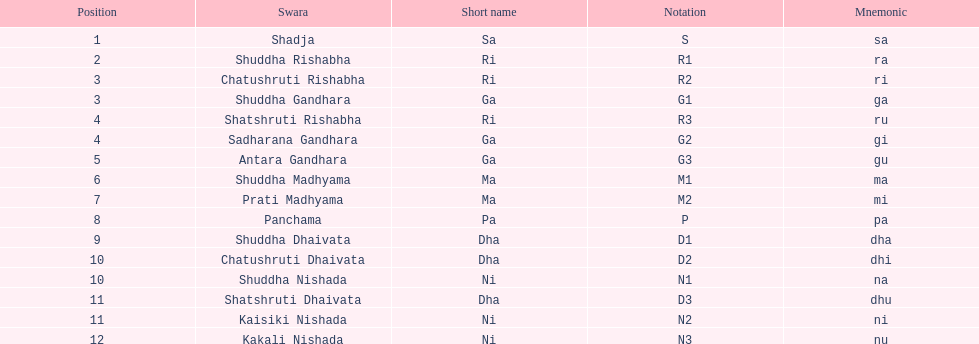Besides m1, how many notations include "1" in them? 4. Give me the full table as a dictionary. {'header': ['Position', 'Swara', 'Short name', 'Notation', 'Mnemonic'], 'rows': [['1', 'Shadja', 'Sa', 'S', 'sa'], ['2', 'Shuddha Rishabha', 'Ri', 'R1', 'ra'], ['3', 'Chatushruti Rishabha', 'Ri', 'R2', 'ri'], ['3', 'Shuddha Gandhara', 'Ga', 'G1', 'ga'], ['4', 'Shatshruti Rishabha', 'Ri', 'R3', 'ru'], ['4', 'Sadharana Gandhara', 'Ga', 'G2', 'gi'], ['5', 'Antara Gandhara', 'Ga', 'G3', 'gu'], ['6', 'Shuddha Madhyama', 'Ma', 'M1', 'ma'], ['7', 'Prati Madhyama', 'Ma', 'M2', 'mi'], ['8', 'Panchama', 'Pa', 'P', 'pa'], ['9', 'Shuddha Dhaivata', 'Dha', 'D1', 'dha'], ['10', 'Chatushruti Dhaivata', 'Dha', 'D2', 'dhi'], ['10', 'Shuddha Nishada', 'Ni', 'N1', 'na'], ['11', 'Shatshruti Dhaivata', 'Dha', 'D3', 'dhu'], ['11', 'Kaisiki Nishada', 'Ni', 'N2', 'ni'], ['12', 'Kakali Nishada', 'Ni', 'N3', 'nu']]} 